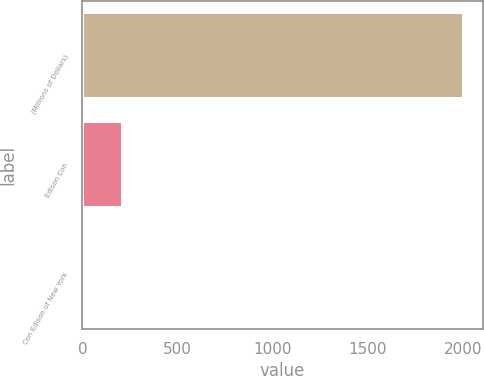Convert chart. <chart><loc_0><loc_0><loc_500><loc_500><bar_chart><fcel>(Millions of Dollars)<fcel>Edison Con<fcel>Con Edison of New York<nl><fcel>2005<fcel>215.8<fcel>17<nl></chart> 